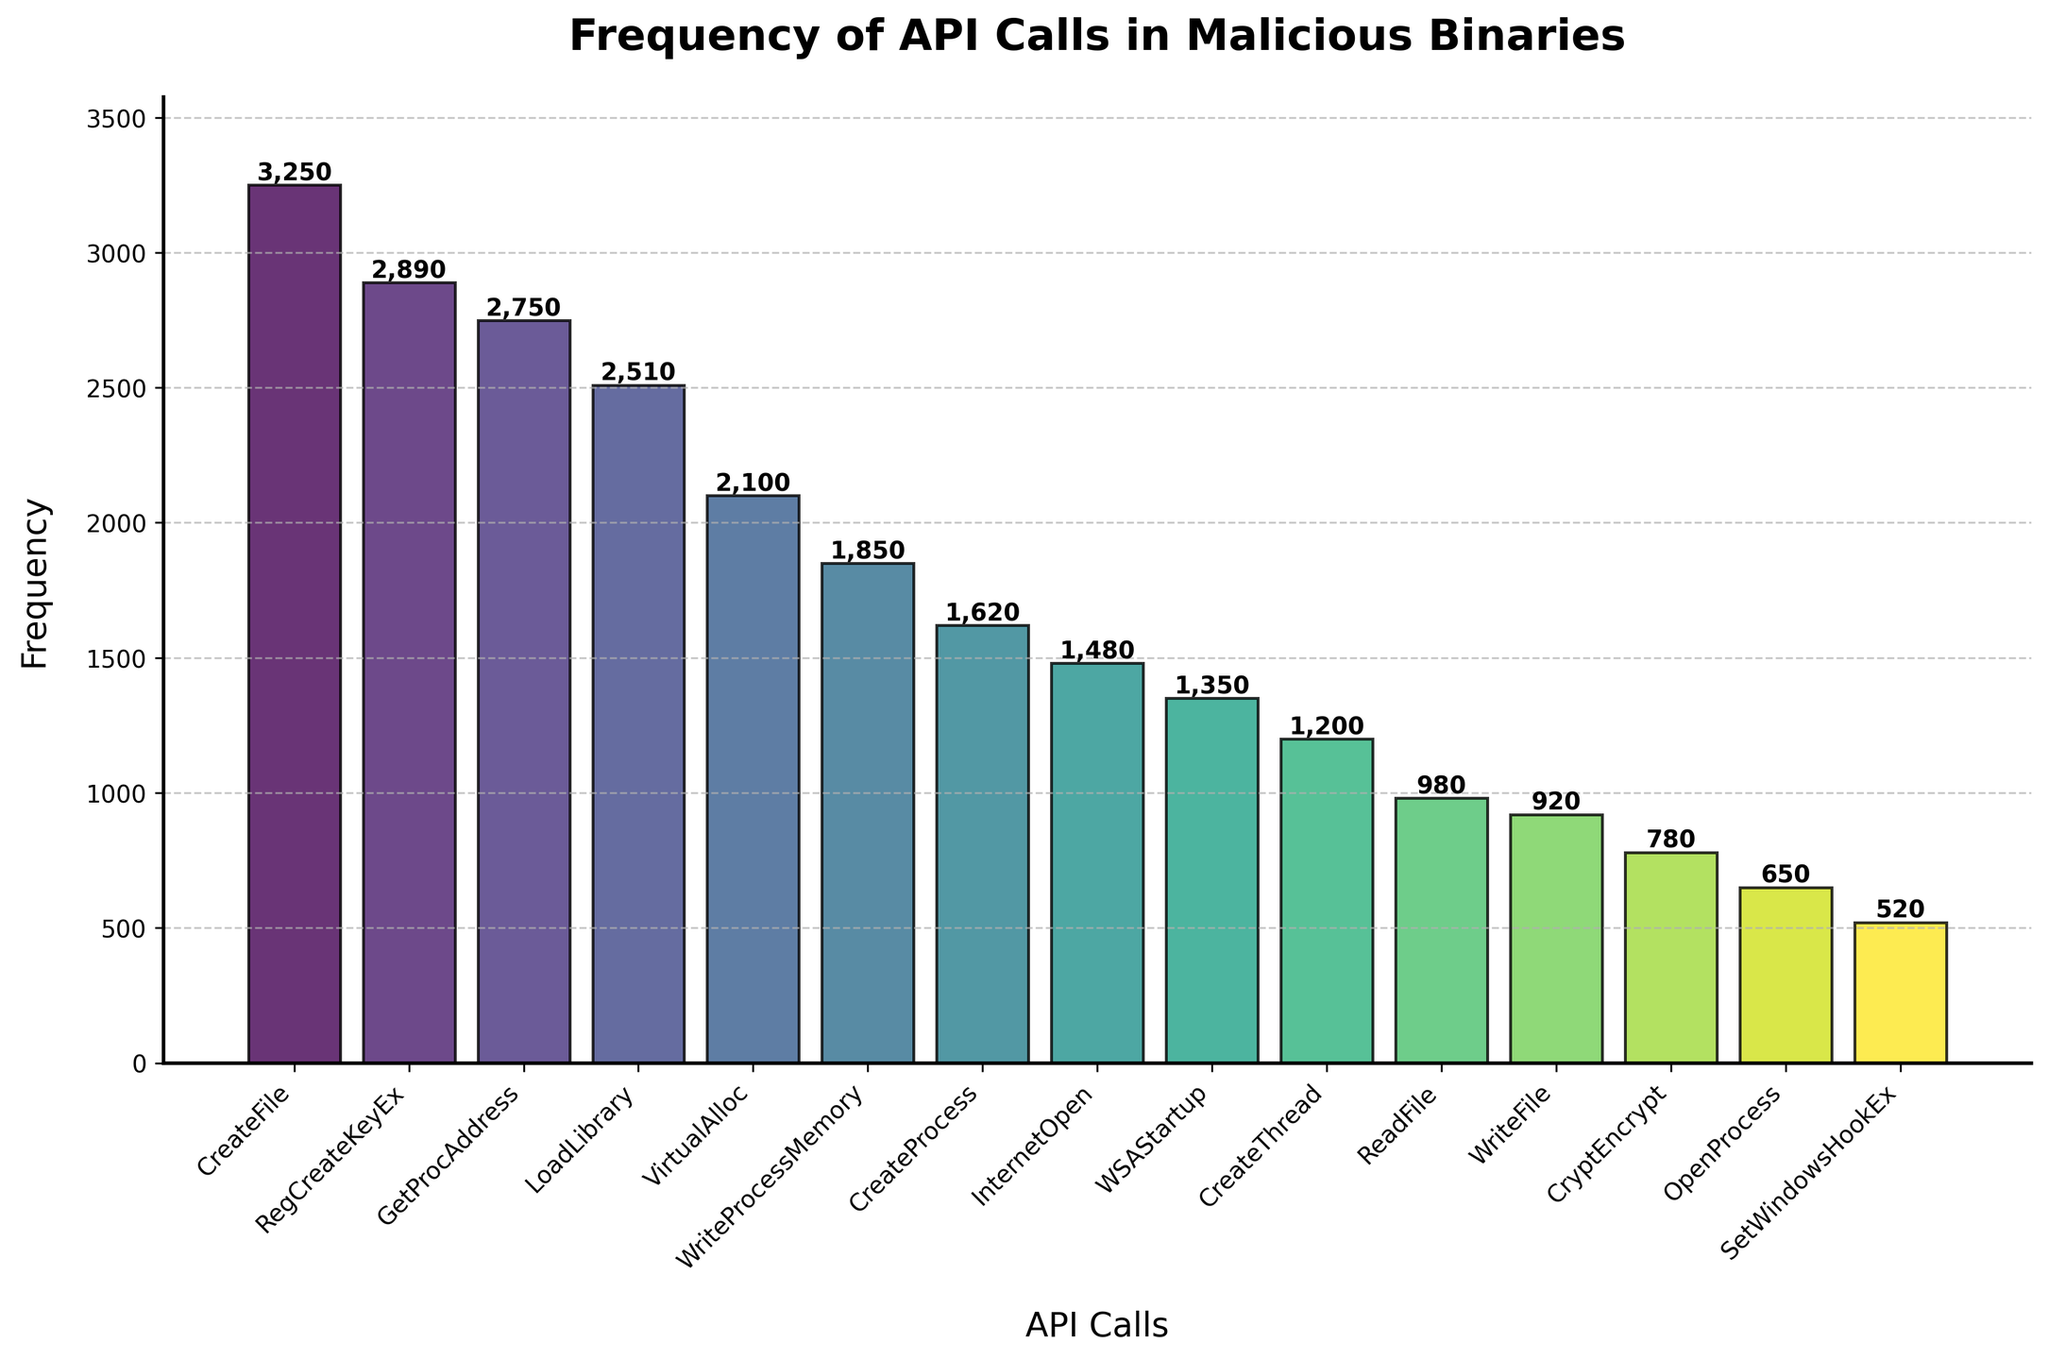What is the title of the figure? The title is usually displayed at the top of the figure. It provides a quick summary of the chart content.
Answer: Frequency of API Calls in Malicious Binaries Which API call has the highest frequency? To identify the API call with the highest frequency, find the bar representing the highest value.
Answer: CreateFile What is the frequency of the 'InternetOpen' API call? Look for the 'InternetOpen' API call on the x-axis, then read its corresponding bar height value on the y-axis.
Answer: 1480 How many API calls have a frequency greater than 2000? Count the number of bars whose height exceeds the 2000 mark on the y-axis.
Answer: 4 What is the difference in frequency between 'CreateProcess' and 'CreateThread'? Find the bars for 'CreateProcess' and 'CreateThread', note their heights, and subtract the smaller value from the larger.
Answer: 1620 - 1200 = 420 Which API call has the lowest frequency, and what is the value? Look for the shortest bar on the chart and read the API call and its corresponding value.
Answer: SetWindowsHookEx, 520 What is the average frequency of the API calls shown? Sum all the frequencies and divide by the number of API calls. The sum is 3250 + 2890 + 2750 + 2510 + 2100 + 1850 + 1620 + 1480 + 1350 + 1200 + 980 + 920 + 780 + 650 + 520 = 28550. There are 15 API calls, so 28550 / 15 = 1903.33.
Answer: 1903.33 Are there more API calls with frequencies above or below 1500? Count the number of API calls with frequencies above 1500 and those below 1500, then compare the counts. There are 9 API calls with frequencies above 1500 and 6 with frequencies below 1500.
Answer: Above How much higher is the frequency of 'CreateFile' compared to 'WriteFile'? Find the frequency values for 'CreateFile' and 'WriteFile', then subtract the latter from the former: 3250 - 920 = 2330.
Answer: 2330 What do the colors of the bars represent? The colors are used to distinguish different API calls visually and are derived from a color gradient. The purpose is purely aesthetic and for better readability.
Answer: Different API calls based on a color gradient 